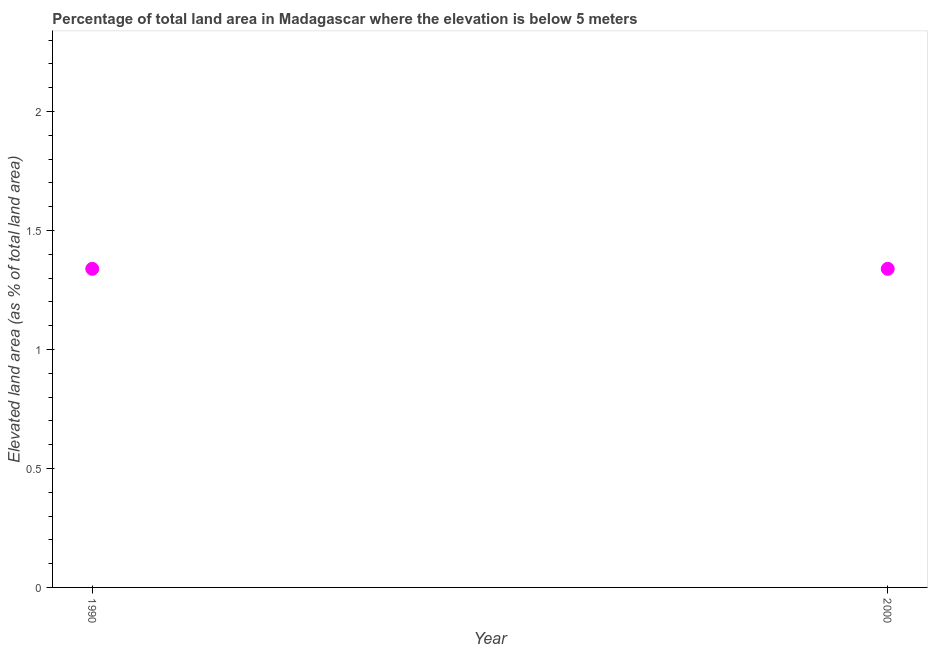What is the total elevated land area in 2000?
Provide a short and direct response. 1.34. Across all years, what is the maximum total elevated land area?
Offer a terse response. 1.34. Across all years, what is the minimum total elevated land area?
Give a very brief answer. 1.34. In which year was the total elevated land area minimum?
Make the answer very short. 1990. What is the sum of the total elevated land area?
Ensure brevity in your answer.  2.68. What is the difference between the total elevated land area in 1990 and 2000?
Your response must be concise. 0. What is the average total elevated land area per year?
Your response must be concise. 1.34. What is the median total elevated land area?
Your response must be concise. 1.34. Does the total elevated land area monotonically increase over the years?
Offer a terse response. No. How many dotlines are there?
Keep it short and to the point. 1. How many years are there in the graph?
Your answer should be very brief. 2. What is the title of the graph?
Your answer should be compact. Percentage of total land area in Madagascar where the elevation is below 5 meters. What is the label or title of the Y-axis?
Offer a terse response. Elevated land area (as % of total land area). What is the Elevated land area (as % of total land area) in 1990?
Provide a short and direct response. 1.34. What is the Elevated land area (as % of total land area) in 2000?
Make the answer very short. 1.34. What is the ratio of the Elevated land area (as % of total land area) in 1990 to that in 2000?
Your response must be concise. 1. 